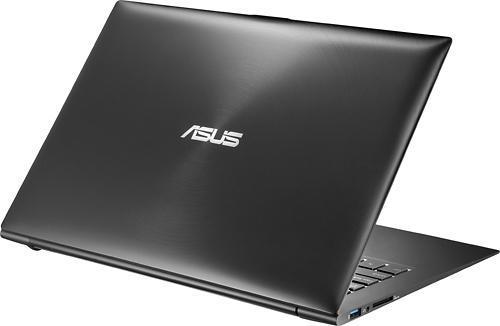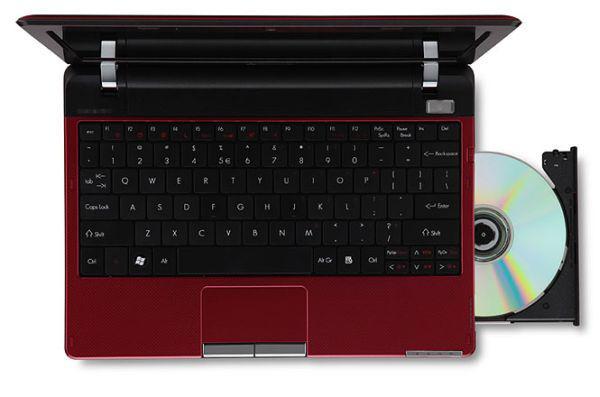The first image is the image on the left, the second image is the image on the right. For the images displayed, is the sentence "The three gray laptops have an open disc drive on the right side of the keyboard." factually correct? Answer yes or no. No. The first image is the image on the left, the second image is the image on the right. Given the left and right images, does the statement "The open laptop on the right is shown in an aerial view with a CD sticking out of the side, while the laptop on the left does not have a CD sticking out." hold true? Answer yes or no. Yes. 